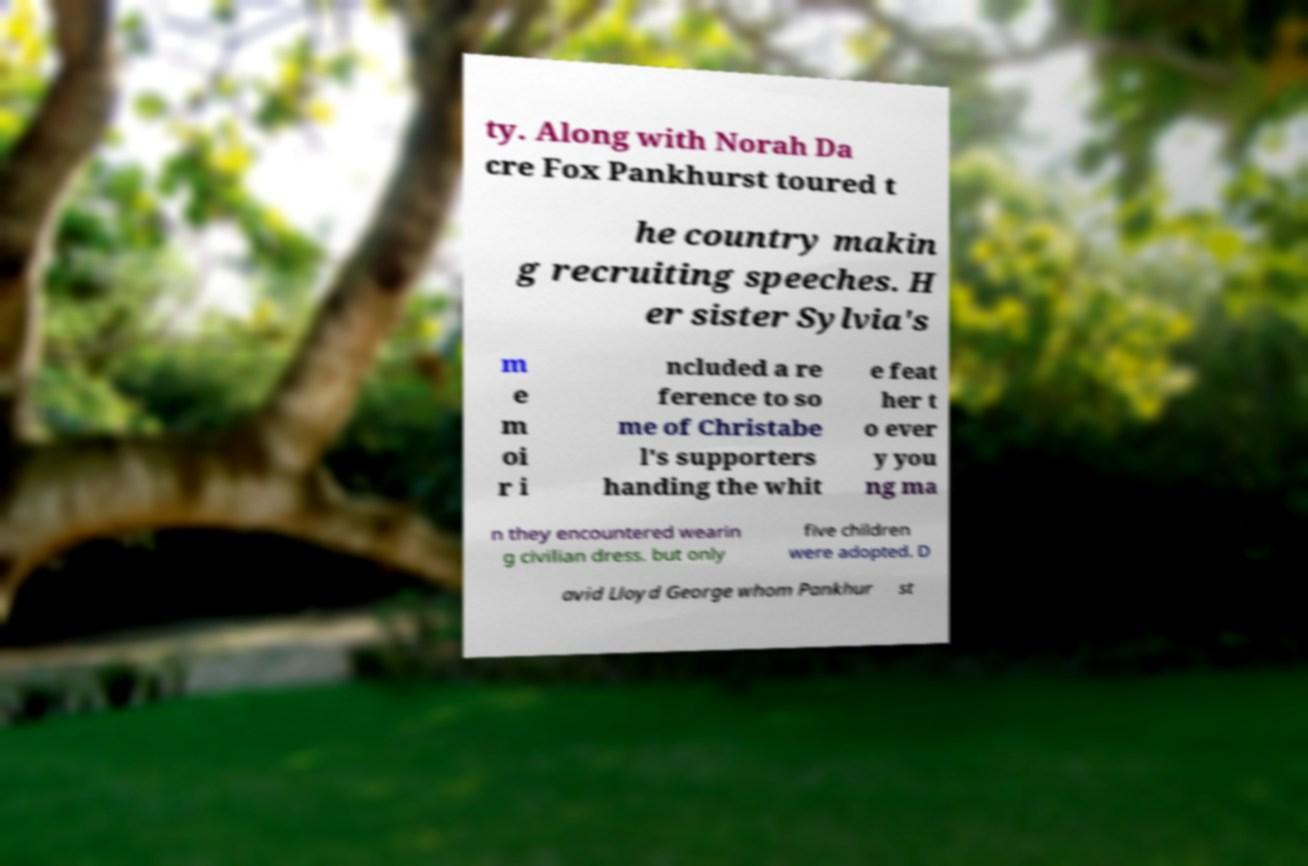Please identify and transcribe the text found in this image. ty. Along with Norah Da cre Fox Pankhurst toured t he country makin g recruiting speeches. H er sister Sylvia's m e m oi r i ncluded a re ference to so me of Christabe l's supporters handing the whit e feat her t o ever y you ng ma n they encountered wearin g civilian dress. but only five children were adopted. D avid Lloyd George whom Pankhur st 